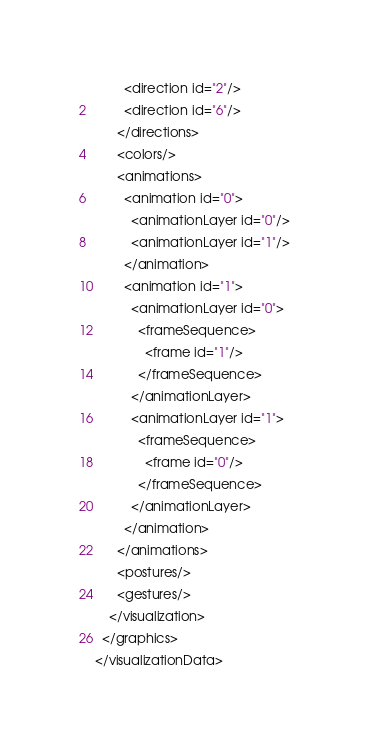Convert code to text. <code><loc_0><loc_0><loc_500><loc_500><_XML_>        <direction id="2"/>
        <direction id="6"/>
      </directions>
      <colors/>
      <animations>
        <animation id="0">
          <animationLayer id="0"/>
          <animationLayer id="1"/>
        </animation>
        <animation id="1">
          <animationLayer id="0">
            <frameSequence>
              <frame id="1"/>
            </frameSequence>
          </animationLayer>
          <animationLayer id="1">
            <frameSequence>
              <frame id="0"/>
            </frameSequence>
          </animationLayer>
        </animation>
      </animations>
      <postures/>
      <gestures/>
    </visualization>
  </graphics>
</visualizationData></code> 